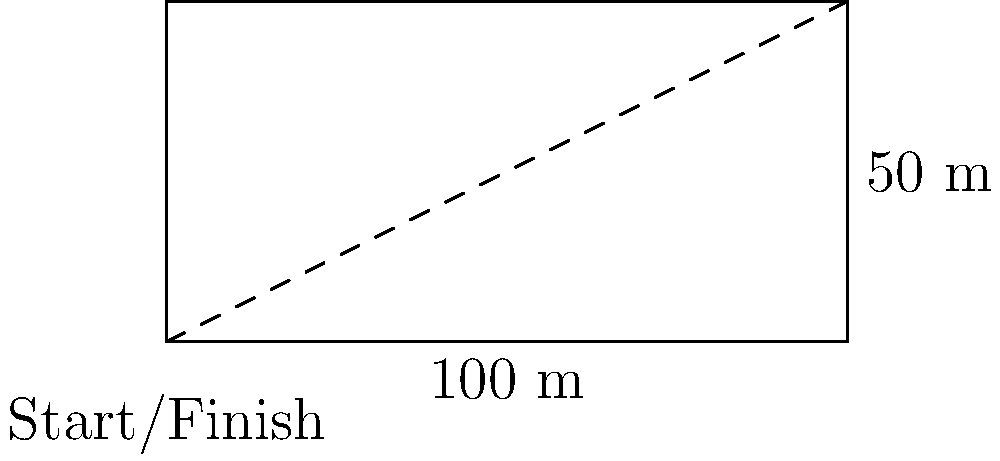A Mauritanian runner completes 4 laps around a track shaped as shown in the diagram. If the runner finishes the race in 3 minutes and 20 seconds, what is their average speed in meters per second (m/s)? Round your answer to two decimal places. To solve this problem, we need to follow these steps:

1. Calculate the total distance:
   - Perimeter of the track = 100 m + 50 m + 100 m + 50 m = 300 m
   - Total distance = 4 laps × 300 m = 1200 m

2. Convert the time to seconds:
   - 3 minutes and 20 seconds = (3 × 60) + 20 = 200 seconds

3. Calculate the average speed using the formula:
   $$ \text{Average Speed} = \frac{\text{Total Distance}}{\text{Total Time}} $$

   $$ \text{Average Speed} = \frac{1200 \text{ m}}{200 \text{ s}} = 6 \text{ m/s} $$

4. Round the result to two decimal places:
   6 m/s (already in two decimal places)

Therefore, the Mauritanian runner's average speed is 6.00 m/s.
Answer: 6.00 m/s 